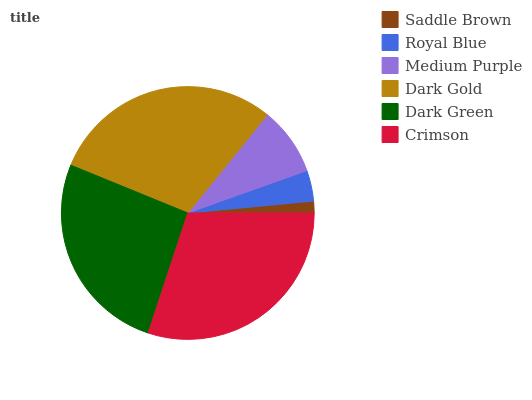Is Saddle Brown the minimum?
Answer yes or no. Yes. Is Crimson the maximum?
Answer yes or no. Yes. Is Royal Blue the minimum?
Answer yes or no. No. Is Royal Blue the maximum?
Answer yes or no. No. Is Royal Blue greater than Saddle Brown?
Answer yes or no. Yes. Is Saddle Brown less than Royal Blue?
Answer yes or no. Yes. Is Saddle Brown greater than Royal Blue?
Answer yes or no. No. Is Royal Blue less than Saddle Brown?
Answer yes or no. No. Is Dark Green the high median?
Answer yes or no. Yes. Is Medium Purple the low median?
Answer yes or no. Yes. Is Dark Gold the high median?
Answer yes or no. No. Is Royal Blue the low median?
Answer yes or no. No. 